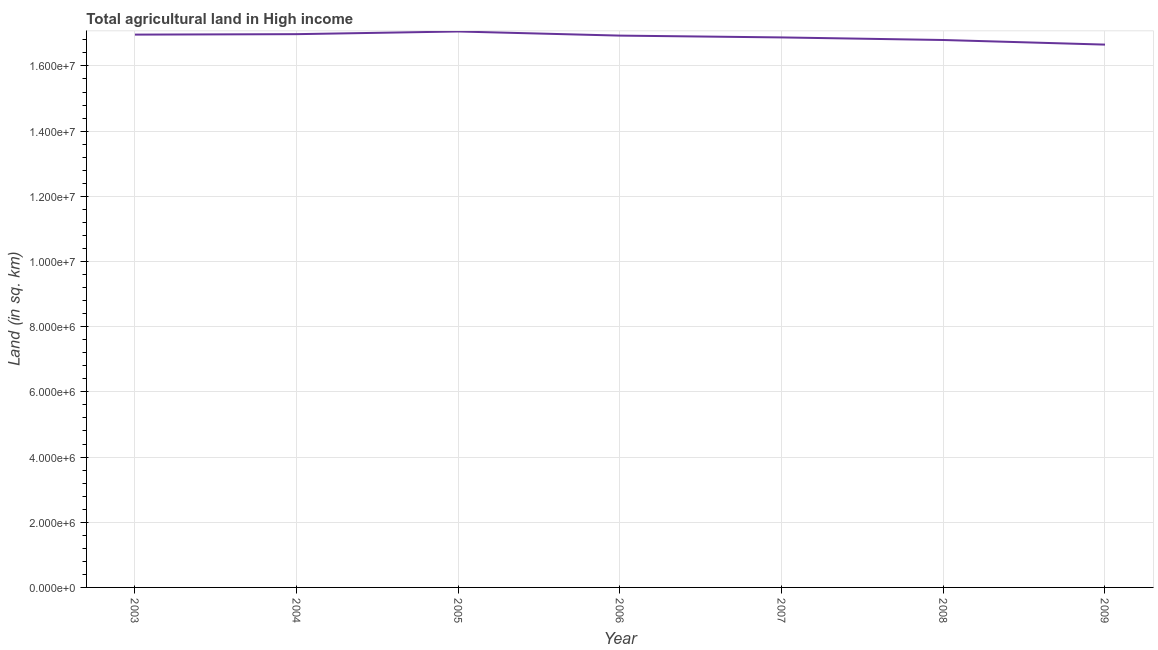What is the agricultural land in 2009?
Keep it short and to the point. 1.67e+07. Across all years, what is the maximum agricultural land?
Keep it short and to the point. 1.71e+07. Across all years, what is the minimum agricultural land?
Your answer should be compact. 1.67e+07. In which year was the agricultural land maximum?
Your answer should be very brief. 2005. What is the sum of the agricultural land?
Offer a terse response. 1.18e+08. What is the difference between the agricultural land in 2005 and 2009?
Make the answer very short. 4.03e+05. What is the average agricultural land per year?
Your answer should be very brief. 1.69e+07. What is the median agricultural land?
Your response must be concise. 1.69e+07. In how many years, is the agricultural land greater than 4800000 sq. km?
Make the answer very short. 7. Do a majority of the years between 2006 and 2004 (inclusive) have agricultural land greater than 11600000 sq. km?
Your response must be concise. No. What is the ratio of the agricultural land in 2004 to that in 2006?
Give a very brief answer. 1. What is the difference between the highest and the second highest agricultural land?
Your response must be concise. 8.22e+04. What is the difference between the highest and the lowest agricultural land?
Ensure brevity in your answer.  4.03e+05. Does the agricultural land monotonically increase over the years?
Provide a succinct answer. No. How many lines are there?
Offer a very short reply. 1. What is the difference between two consecutive major ticks on the Y-axis?
Your answer should be very brief. 2.00e+06. Are the values on the major ticks of Y-axis written in scientific E-notation?
Provide a succinct answer. Yes. Does the graph contain any zero values?
Ensure brevity in your answer.  No. Does the graph contain grids?
Provide a succinct answer. Yes. What is the title of the graph?
Give a very brief answer. Total agricultural land in High income. What is the label or title of the Y-axis?
Your answer should be very brief. Land (in sq. km). What is the Land (in sq. km) of 2003?
Provide a succinct answer. 1.70e+07. What is the Land (in sq. km) in 2004?
Your answer should be compact. 1.70e+07. What is the Land (in sq. km) of 2005?
Ensure brevity in your answer.  1.71e+07. What is the Land (in sq. km) in 2006?
Your answer should be very brief. 1.69e+07. What is the Land (in sq. km) in 2007?
Give a very brief answer. 1.69e+07. What is the Land (in sq. km) in 2008?
Keep it short and to the point. 1.68e+07. What is the Land (in sq. km) of 2009?
Your answer should be compact. 1.67e+07. What is the difference between the Land (in sq. km) in 2003 and 2004?
Give a very brief answer. -1.40e+04. What is the difference between the Land (in sq. km) in 2003 and 2005?
Keep it short and to the point. -9.62e+04. What is the difference between the Land (in sq. km) in 2003 and 2006?
Give a very brief answer. 3.05e+04. What is the difference between the Land (in sq. km) in 2003 and 2007?
Your answer should be very brief. 8.61e+04. What is the difference between the Land (in sq. km) in 2003 and 2008?
Make the answer very short. 1.65e+05. What is the difference between the Land (in sq. km) in 2003 and 2009?
Provide a succinct answer. 3.07e+05. What is the difference between the Land (in sq. km) in 2004 and 2005?
Your answer should be compact. -8.22e+04. What is the difference between the Land (in sq. km) in 2004 and 2006?
Offer a very short reply. 4.45e+04. What is the difference between the Land (in sq. km) in 2004 and 2007?
Offer a terse response. 1.00e+05. What is the difference between the Land (in sq. km) in 2004 and 2008?
Your response must be concise. 1.79e+05. What is the difference between the Land (in sq. km) in 2004 and 2009?
Keep it short and to the point. 3.21e+05. What is the difference between the Land (in sq. km) in 2005 and 2006?
Your answer should be very brief. 1.27e+05. What is the difference between the Land (in sq. km) in 2005 and 2007?
Offer a terse response. 1.82e+05. What is the difference between the Land (in sq. km) in 2005 and 2008?
Provide a short and direct response. 2.61e+05. What is the difference between the Land (in sq. km) in 2005 and 2009?
Provide a succinct answer. 4.03e+05. What is the difference between the Land (in sq. km) in 2006 and 2007?
Provide a short and direct response. 5.55e+04. What is the difference between the Land (in sq. km) in 2006 and 2008?
Offer a terse response. 1.34e+05. What is the difference between the Land (in sq. km) in 2006 and 2009?
Your answer should be compact. 2.76e+05. What is the difference between the Land (in sq. km) in 2007 and 2008?
Offer a terse response. 7.89e+04. What is the difference between the Land (in sq. km) in 2007 and 2009?
Your response must be concise. 2.21e+05. What is the difference between the Land (in sq. km) in 2008 and 2009?
Your answer should be very brief. 1.42e+05. What is the ratio of the Land (in sq. km) in 2003 to that in 2005?
Keep it short and to the point. 0.99. What is the ratio of the Land (in sq. km) in 2003 to that in 2006?
Offer a very short reply. 1. What is the ratio of the Land (in sq. km) in 2003 to that in 2007?
Provide a short and direct response. 1. What is the ratio of the Land (in sq. km) in 2004 to that in 2007?
Offer a very short reply. 1.01. What is the ratio of the Land (in sq. km) in 2004 to that in 2008?
Offer a terse response. 1.01. What is the ratio of the Land (in sq. km) in 2005 to that in 2006?
Keep it short and to the point. 1.01. What is the ratio of the Land (in sq. km) in 2005 to that in 2008?
Your answer should be compact. 1.02. What is the ratio of the Land (in sq. km) in 2006 to that in 2007?
Your answer should be compact. 1. What is the ratio of the Land (in sq. km) in 2006 to that in 2008?
Your response must be concise. 1.01. What is the ratio of the Land (in sq. km) in 2007 to that in 2009?
Offer a very short reply. 1.01. 